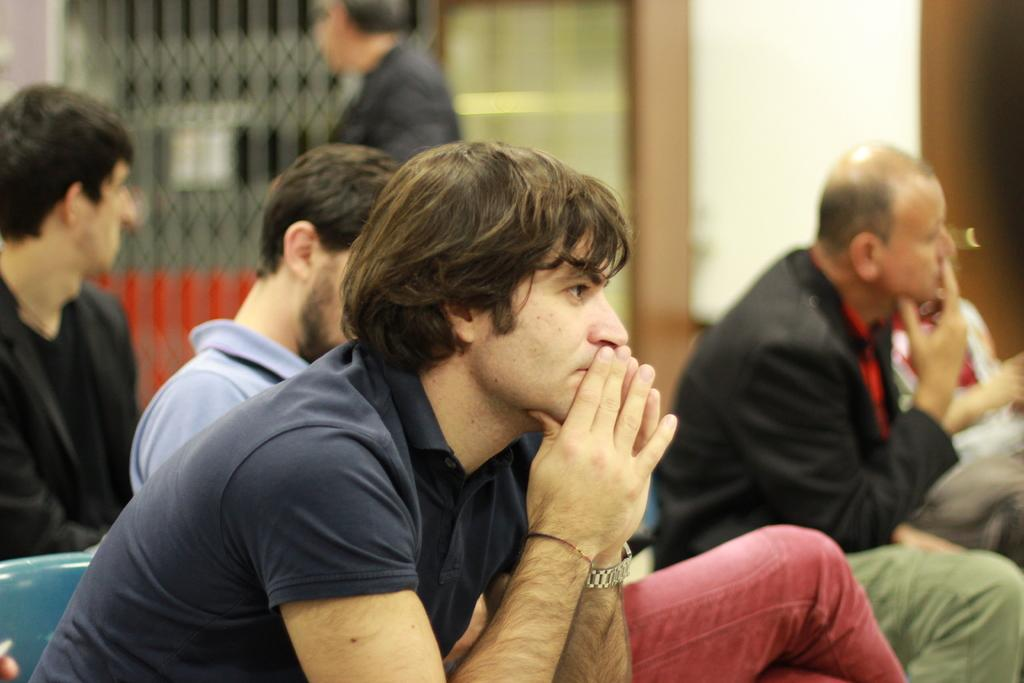What are the people in the image doing? There is a group of people sitting in the image. Is there anyone standing in the image? Yes, there is a person standing in the image. What can be seen in the background of the image? There are blurred objects in the background of the image. What type of riddle can be solved by the person standing in the image? There is no riddle present in the image, and therefore no such activity can be solved by the person standing. 